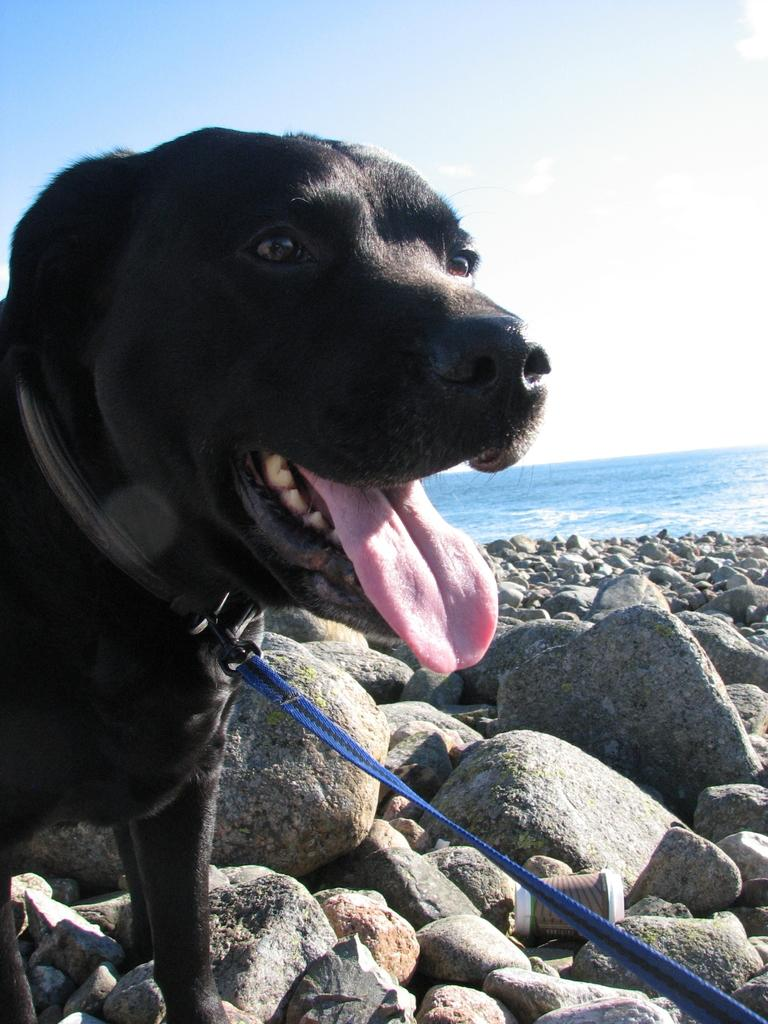What type of animal is in the image? There is a dog in the image. What is the dog wearing? The dog is wearing a belt. What type of natural elements can be seen in the image? There are stones and water visible in the image. What is the man-made object in the image? There is a glass in the image. What is visible in the background of the image? The sky is visible in the background of the image. Can you see the veins in the rabbit's ears in the image? There is no rabbit present in the image, only a dog. What type of tray is being used to serve the food in the image? There is no tray visible in the image; it only features a dog, a belt, stones, water, a glass, and the sky. 